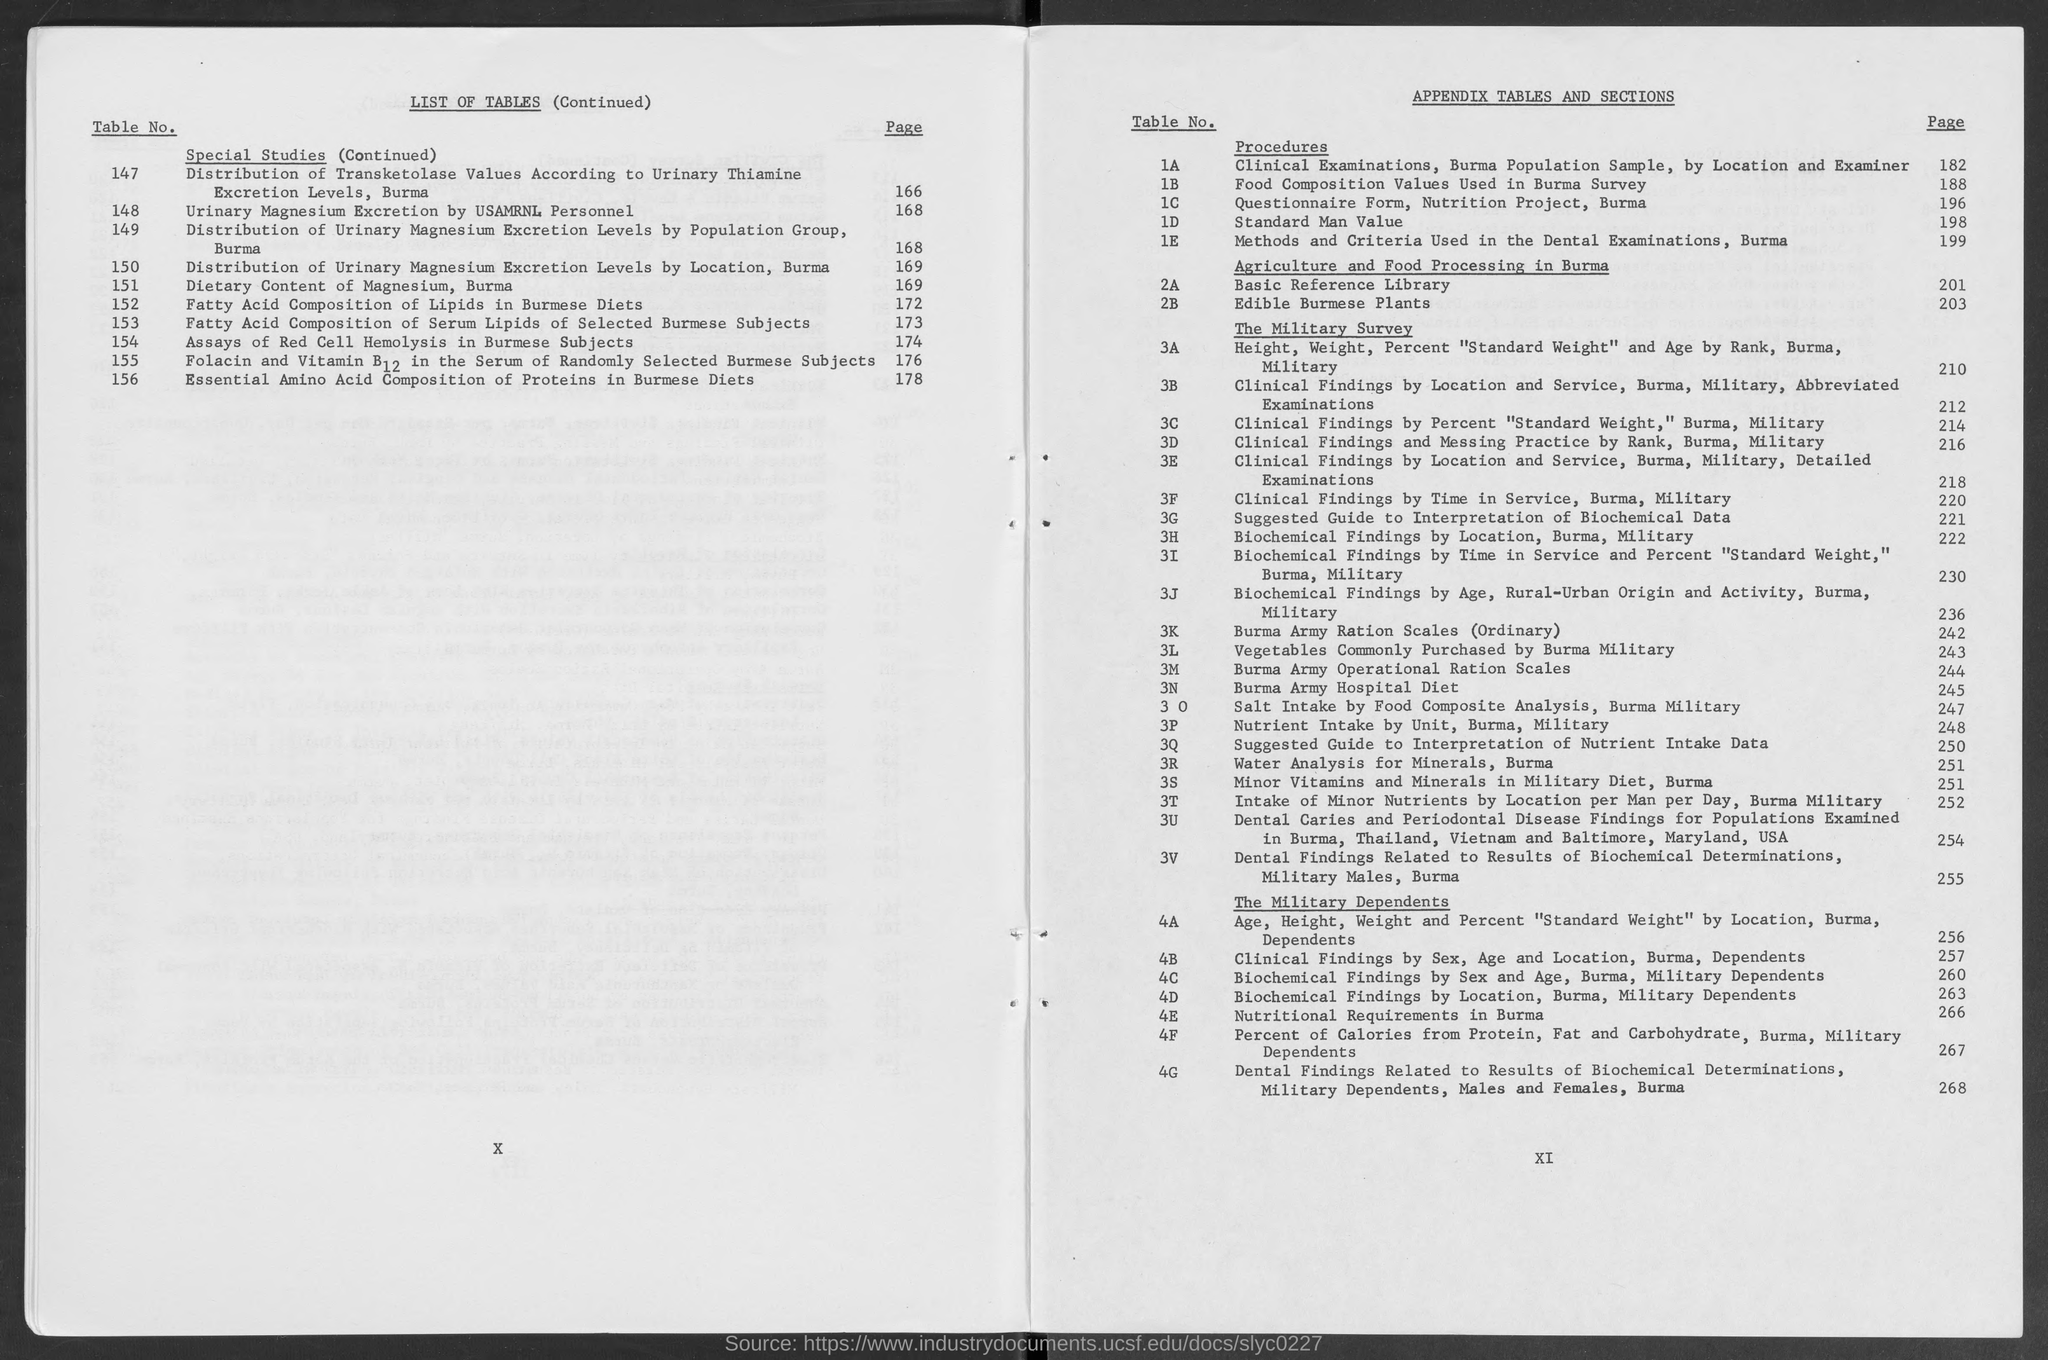What is the page number for table no. 1a?
Provide a succinct answer. 182. What is the page number for table no. 1b?
Provide a succinct answer. 188. What is the page number for table no. 1c?
Give a very brief answer. 196. What is the page number for table no. 1d?
Offer a terse response. 198. What is the page number for table no. 1e?
Keep it short and to the point. 199. What is the page number for table no. 2a?
Offer a terse response. 201. What is the page number for table no. 2b?
Make the answer very short. 203. What is the page number for table no. 3a?
Ensure brevity in your answer.  210. What is the page number for table no. 3b?
Your answer should be very brief. 212. What is the page number for table no. 3c?
Provide a succinct answer. 214. 